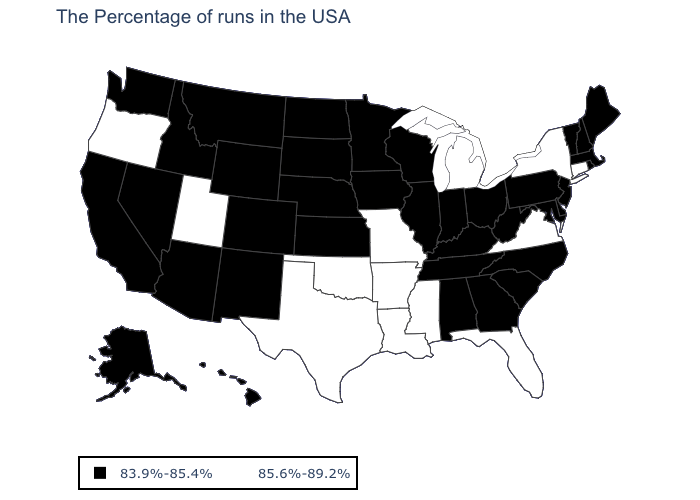Is the legend a continuous bar?
Concise answer only. No. Name the states that have a value in the range 83.9%-85.4%?
Be succinct. Maine, Massachusetts, Rhode Island, New Hampshire, Vermont, New Jersey, Delaware, Maryland, Pennsylvania, North Carolina, South Carolina, West Virginia, Ohio, Georgia, Kentucky, Indiana, Alabama, Tennessee, Wisconsin, Illinois, Minnesota, Iowa, Kansas, Nebraska, South Dakota, North Dakota, Wyoming, Colorado, New Mexico, Montana, Arizona, Idaho, Nevada, California, Washington, Alaska, Hawaii. Does the map have missing data?
Keep it brief. No. Which states have the highest value in the USA?
Keep it brief. Connecticut, New York, Virginia, Florida, Michigan, Mississippi, Louisiana, Missouri, Arkansas, Oklahoma, Texas, Utah, Oregon. What is the lowest value in the Northeast?
Keep it brief. 83.9%-85.4%. Does the map have missing data?
Write a very short answer. No. What is the value of New Mexico?
Give a very brief answer. 83.9%-85.4%. Name the states that have a value in the range 85.6%-89.2%?
Be succinct. Connecticut, New York, Virginia, Florida, Michigan, Mississippi, Louisiana, Missouri, Arkansas, Oklahoma, Texas, Utah, Oregon. Does the map have missing data?
Be succinct. No. What is the highest value in states that border Mississippi?
Keep it brief. 85.6%-89.2%. What is the lowest value in the USA?
Quick response, please. 83.9%-85.4%. Does Washington have the lowest value in the West?
Write a very short answer. Yes. What is the value of Idaho?
Keep it brief. 83.9%-85.4%. Name the states that have a value in the range 83.9%-85.4%?
Write a very short answer. Maine, Massachusetts, Rhode Island, New Hampshire, Vermont, New Jersey, Delaware, Maryland, Pennsylvania, North Carolina, South Carolina, West Virginia, Ohio, Georgia, Kentucky, Indiana, Alabama, Tennessee, Wisconsin, Illinois, Minnesota, Iowa, Kansas, Nebraska, South Dakota, North Dakota, Wyoming, Colorado, New Mexico, Montana, Arizona, Idaho, Nevada, California, Washington, Alaska, Hawaii. 